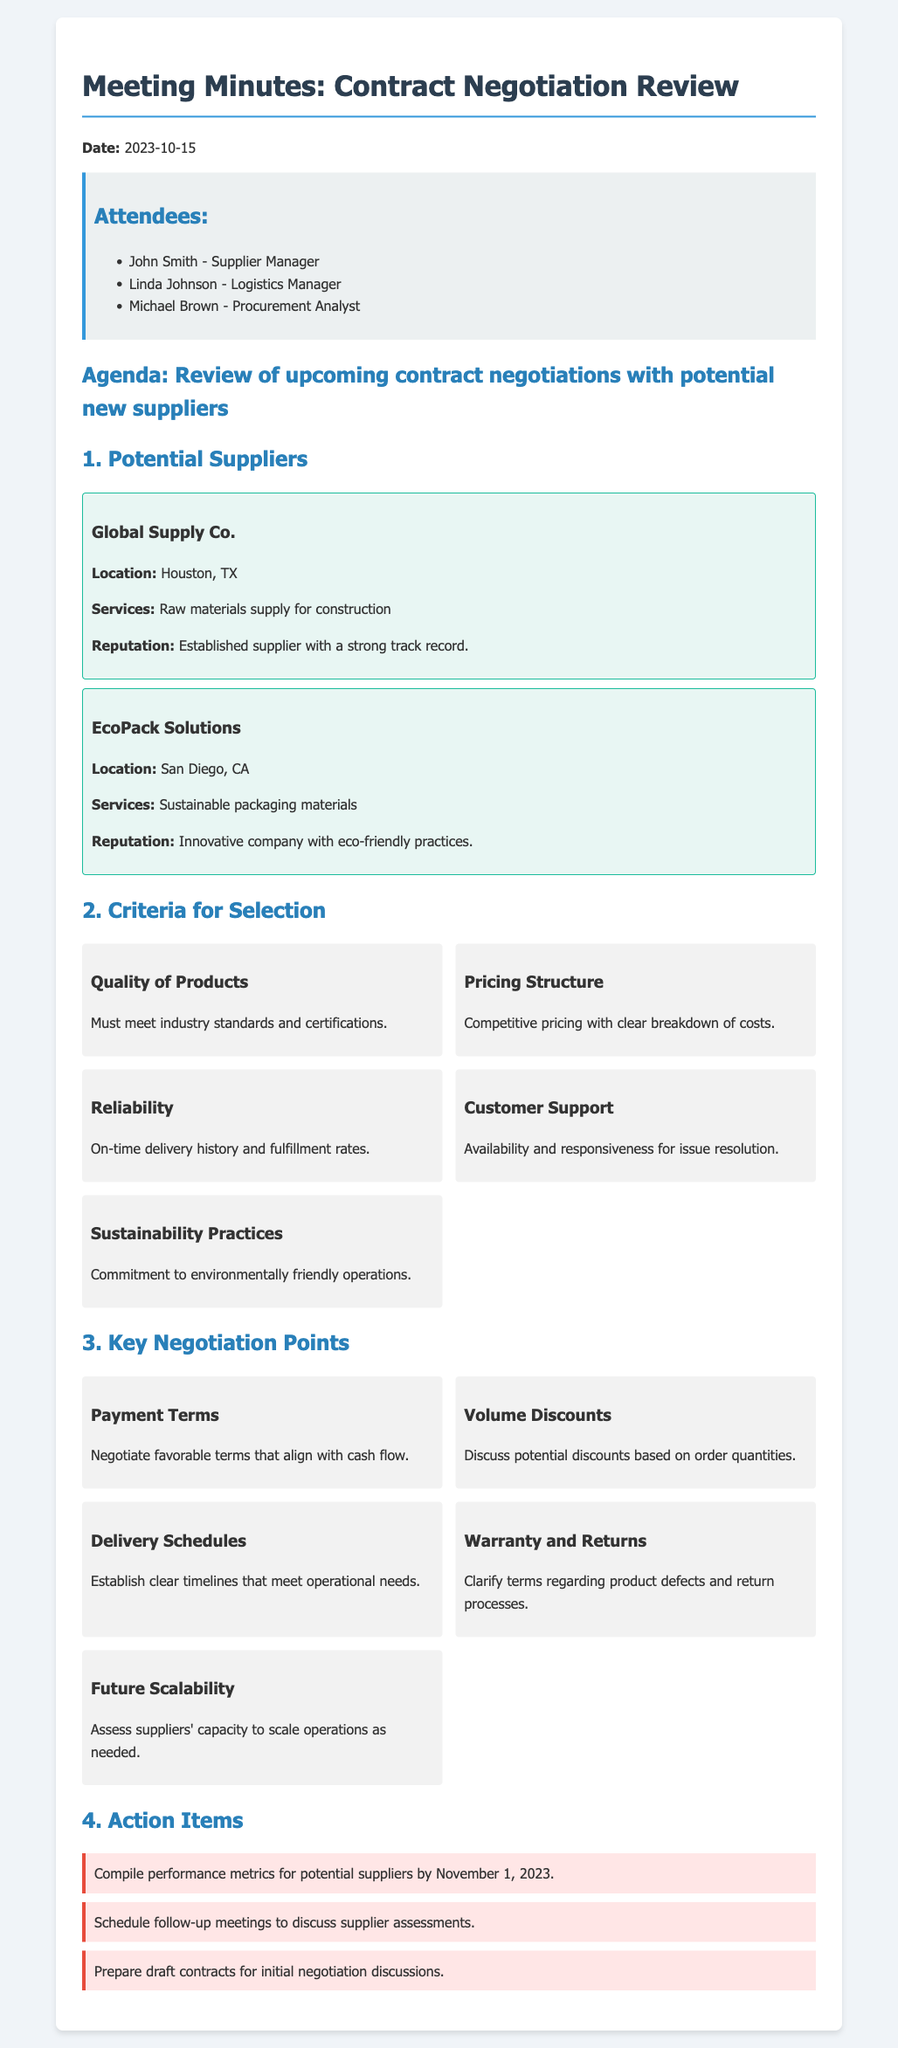what is the date of the meeting? The date of the meeting is explicitly mentioned in the document as October 15, 2023.
Answer: October 15, 2023 who is the logistics manager? The name of the logistics manager is listed among the attendees of the meeting.
Answer: Linda Johnson what are the services provided by Global Supply Co.? The services provided by Global Supply Co. include raw materials supply for construction as stated in the document.
Answer: Raw materials supply for construction what is one of the criteria for selection? The document lists various criteria for selection, one of which is the quality of products.
Answer: Quality of Products what is the location of EcoPack Solutions? The location of EcoPack Solutions is specified in the document as San Diego, CA.
Answer: San Diego, CA what is the primary focus of sustainable practices for suppliers? The document mentions sustainability practices focusing on commitment to environmentally friendly operations.
Answer: Environmentally friendly operations how many action items are listed? The number of action items is quantified in the section dedicated to them in the document.
Answer: Three what is one key negotiation point related to delivery? The document specifies a negotiation point that relates to delivery schedules.
Answer: Delivery Schedules who is responsible for compiling performance metrics? The action item indicates that someone needs to compile performance metrics for potential suppliers.
Answer: Undefined (not specified) 